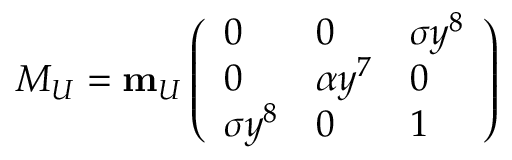Convert formula to latex. <formula><loc_0><loc_0><loc_500><loc_500>M _ { U } = { m } _ { U } \left ( \begin{array} { l l l } { 0 } & { 0 } & { { \sigma y ^ { 8 } } } \\ { 0 } & { { \alpha y ^ { 7 } } } & { 0 } \\ { { \sigma y ^ { 8 } } } & { 0 } & { 1 } \end{array} \right )</formula> 